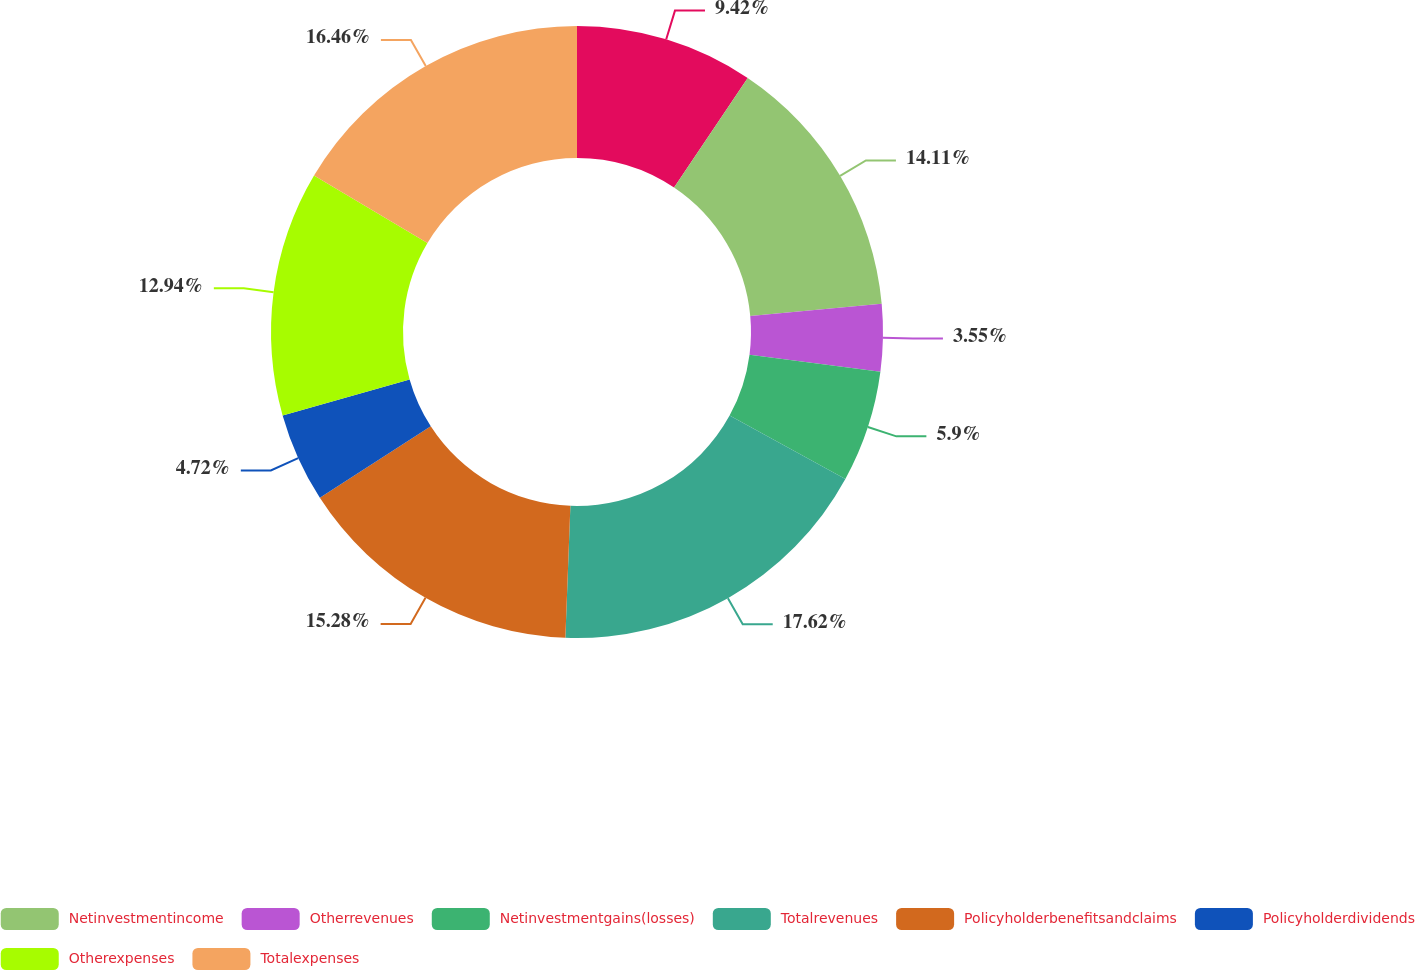Convert chart to OTSL. <chart><loc_0><loc_0><loc_500><loc_500><pie_chart><ecel><fcel>Netinvestmentincome<fcel>Otherrevenues<fcel>Netinvestmentgains(losses)<fcel>Totalrevenues<fcel>Policyholderbenefitsandclaims<fcel>Policyholderdividends<fcel>Otherexpenses<fcel>Totalexpenses<nl><fcel>9.42%<fcel>14.11%<fcel>3.55%<fcel>5.9%<fcel>17.63%<fcel>15.28%<fcel>4.72%<fcel>12.94%<fcel>16.46%<nl></chart> 